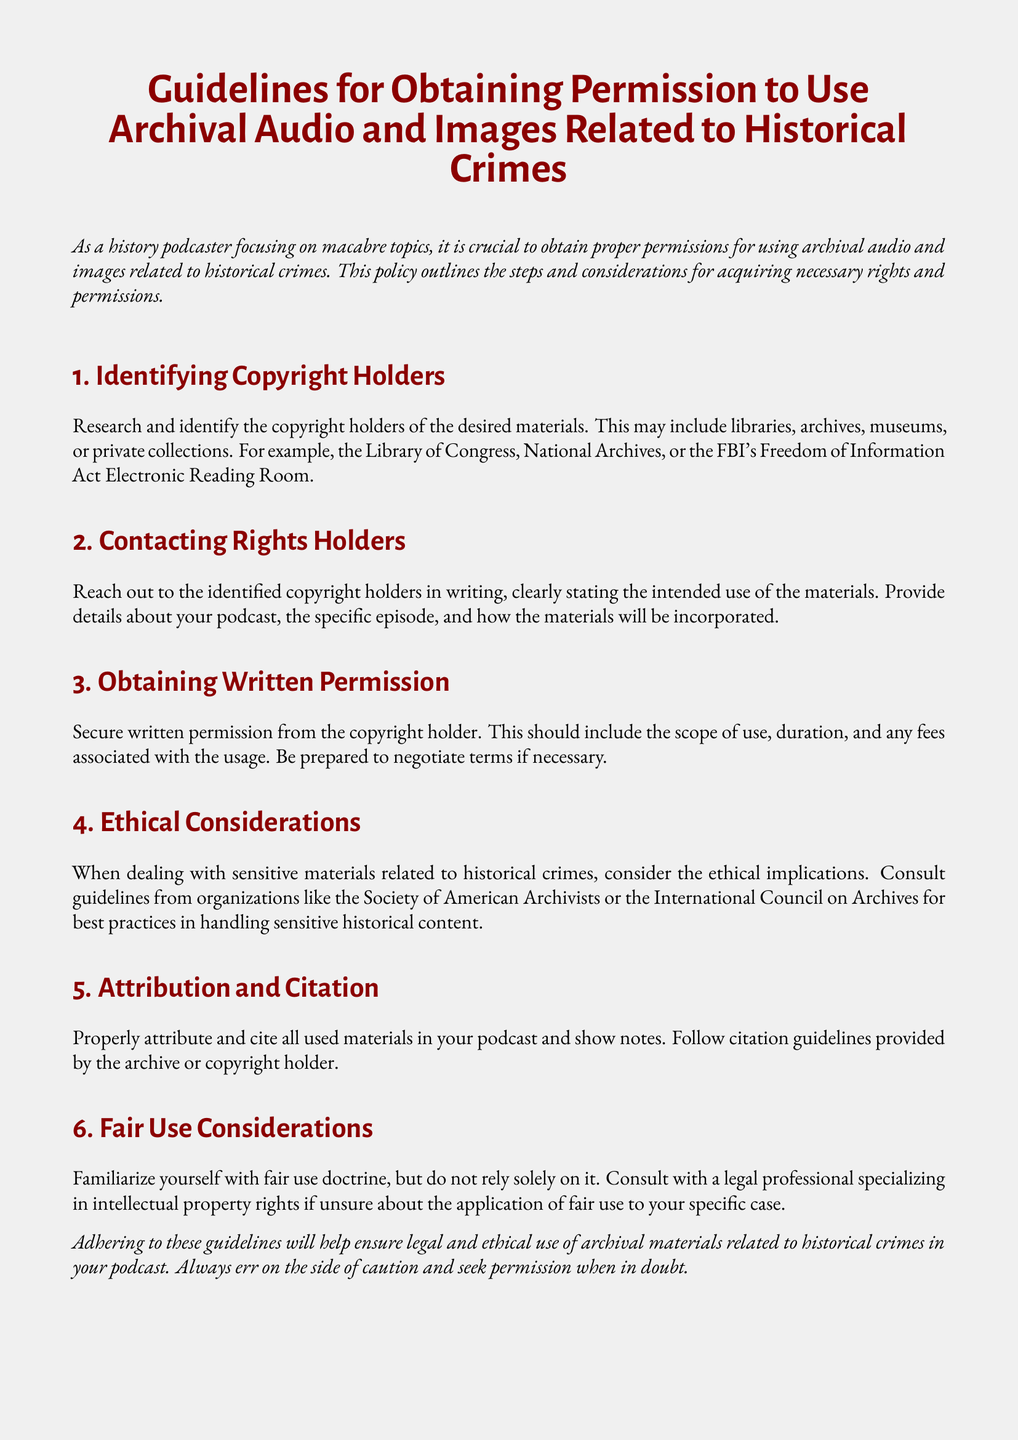What is the document about? The document outlines the steps and considerations for acquiring necessary rights and permissions for using archival audio and images related to historical crimes.
Answer: Guidelines for obtaining permission Who should you contact for rights to materials? The document specifies that you should reach out to identified copyright holders such as libraries, archives, or museums.
Answer: Copyright holders What type of permission should you obtain? The document states that you should secure written permission from the copyright holder.
Answer: Written permission Which organization is mentioned for ethical considerations? The document mentions consulting guidelines from the Society of American Archivists for best practices.
Answer: Society of American Archivists What should be included in your written request? The request should clearly state the intended use of the materials and provide details about the podcast and episode.
Answer: Intended use What is advised regarding fair use? The document advises familiarizing yourself with fair use doctrine but not to rely solely on it.
Answer: Do not rely solely on it What should you do if unsure about fair use? The document recommends consulting with a legal professional specializing in intellectual property rights.
Answer: Consult a legal professional What is essential when using sensitive materials? The document emphasizes considering the ethical implications when dealing with sensitive materials.
Answer: Ethical implications What should be included in the podcast show notes? The document states that all used materials should be properly attributed and cited.
Answer: Attribution and citation 